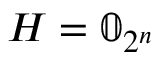Convert formula to latex. <formula><loc_0><loc_0><loc_500><loc_500>H = \mathbb { 0 } _ { 2 ^ { n } }</formula> 